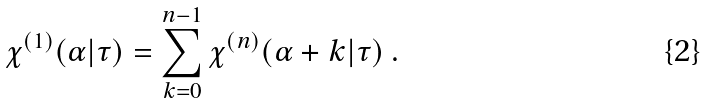Convert formula to latex. <formula><loc_0><loc_0><loc_500><loc_500>\chi ^ { ( 1 ) } ( \alpha | \tau ) = \sum _ { k = 0 } ^ { n - 1 } \chi ^ { ( n ) } ( \alpha + k | \tau ) \ .</formula> 